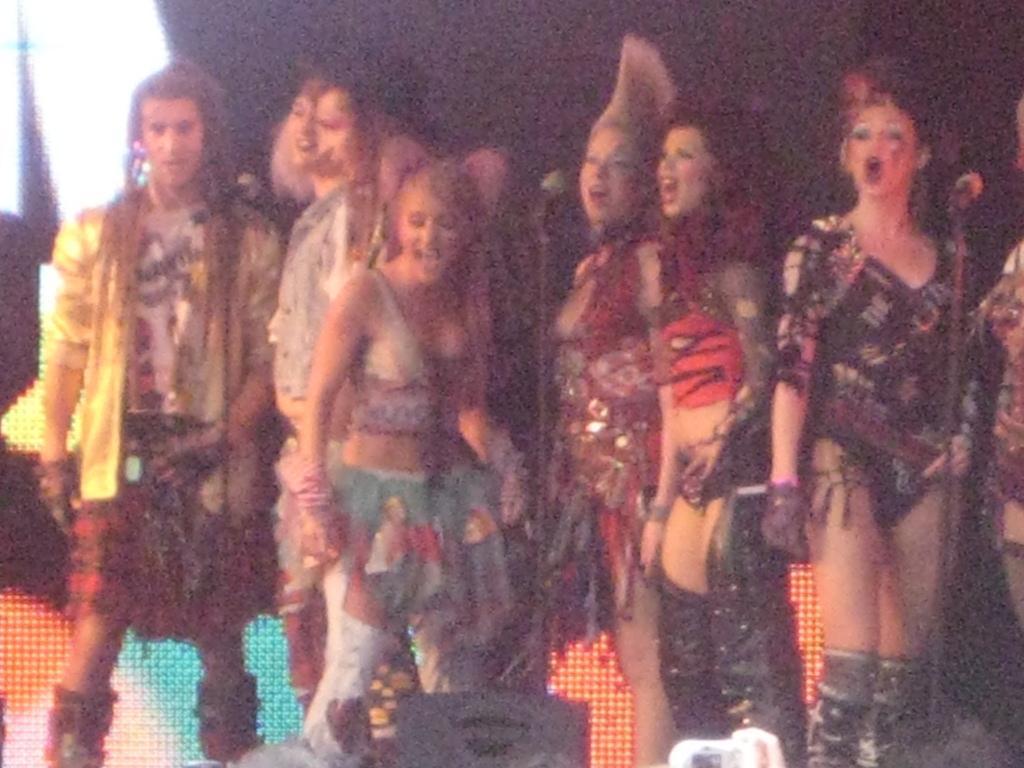Could you give a brief overview of what you see in this image? In this image I can see in the middle a group of girls are wearing the costumes, on the left side few men are shouting. 